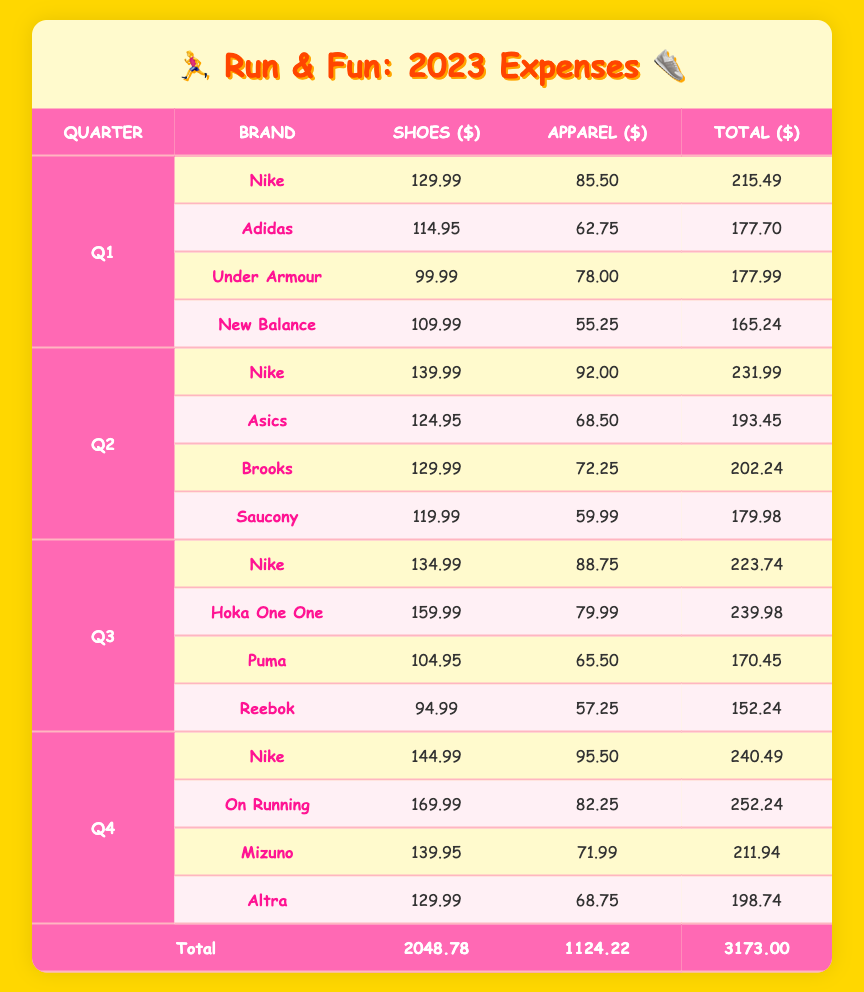What are the total expenses for Nike in Q1? In Q1, Nike spent 129.99 on shoes and 85.50 on apparel. Adding these amounts gives 129.99 + 85.50 = 215.49.
Answer: 215.49 Which brand had the highest shoe expense in Q3? In Q3, the shoe expenses are as follows: Nike (134.99), Hoka One One (159.99), Puma (104.95), and Reebok (94.99). Comparing these amounts, Hoka One One had the highest expense at 159.99.
Answer: Hoka One One What is the total expense for all brands in Q4? In Q4, the total expenses for each brand are: Nike (240.49), On Running (252.24), Mizuno (211.94), and Altra (198.74). Adding these totals gives 240.49 + 252.24 + 211.94 + 198.74 = 903.41.
Answer: 903.41 Did Adidas have a higher apparel expense than Under Armour in Q1? In Q1, Adidas spent 62.75 on apparel and Under Armour spent 78.00. Since 62.75 is less than 78.00, Adidas did not have a higher expense.
Answer: No What is the average shoe expense across all quarters for New Balance? For New Balance, the shoe expenses are: Q1 (109.99), Q2 (0), Q3 (0), and Q4 (0). (Note: Q2, Q3, and Q4 did not have expenses for New Balance). The total shoe expense is 109.99, and since there is only one recorded expense, the average is simply 109.99/1 = 109.99.
Answer: 109.99 Which brands together had apparel expenses over 150 in Q2? In Q2, the apparel expenses are: Nike (92.00), Asics (68.50), Brooks (72.25), and Saucony (59.99). The combined expenses of Nike and Asics equals 92.00 + 68.50 = 160.50, which exceeds 150. Thus, both Nike and Asics fit the criteria.
Answer: Nike and Asics In which quarter did Saucony have the lowest total expenses among the quarters? Saucony's total expenses were only available in Q2, where they spent 119.99 on shoes and 59.99 on apparel, which totals 179.98. Since Saucony does not appear in other quarters, this is their lowest total expense.
Answer: Q2 Is it true that Mizuno had higher total expenses than Altra in Q4? In Q4, Mizuno had total expenses of 211.94 and Altra had total expenses of 198.74. Since 211.94 is greater than 198.74, it is indeed true.
Answer: Yes 